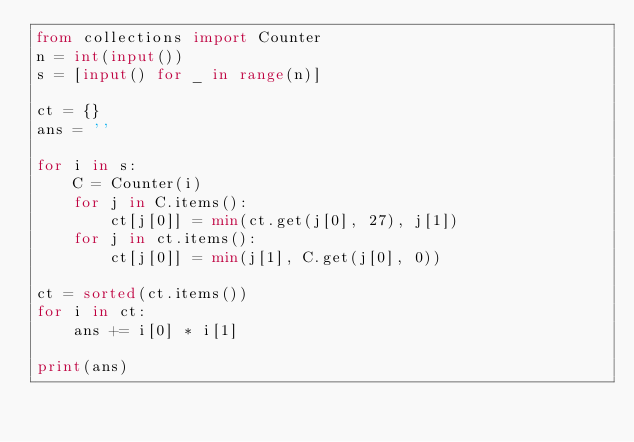<code> <loc_0><loc_0><loc_500><loc_500><_Python_>from collections import Counter
n = int(input())
s = [input() for _ in range(n)]

ct = {}
ans = ''

for i in s:
    C = Counter(i)
    for j in C.items():
        ct[j[0]] = min(ct.get(j[0], 27), j[1])
    for j in ct.items():
        ct[j[0]] = min(j[1], C.get(j[0], 0))

ct = sorted(ct.items())
for i in ct:
    ans += i[0] * i[1]

print(ans)</code> 